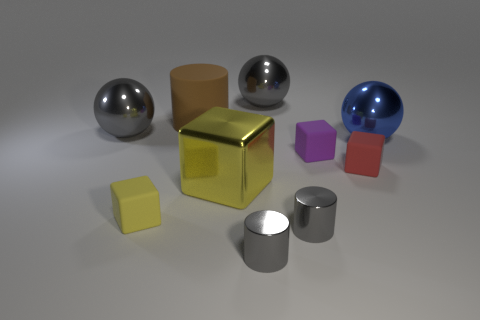There is a cube that is both on the left side of the purple matte cube and to the right of the big brown matte object; what color is it?
Provide a short and direct response. Yellow. Is there a tiny yellow cube that is to the right of the large thing that is in front of the blue metallic sphere?
Provide a succinct answer. No. Are there the same number of purple matte blocks to the right of the red rubber object and big brown cylinders?
Provide a short and direct response. No. There is a tiny matte block that is to the left of the big gray ball to the right of the large yellow shiny block; what number of large blue shiny spheres are to the right of it?
Give a very brief answer. 1. Is there a shiny cube of the same size as the brown matte cylinder?
Keep it short and to the point. Yes. Are there fewer blue spheres that are left of the big blue shiny thing than small gray shiny objects?
Make the answer very short. Yes. What is the material of the gray sphere in front of the cylinder that is behind the red cube that is behind the large yellow metallic thing?
Your answer should be very brief. Metal. Is the number of yellow shiny things that are left of the small red cube greater than the number of tiny things in front of the large brown cylinder?
Give a very brief answer. No. What number of rubber objects are either brown spheres or blue spheres?
Keep it short and to the point. 0. What shape is the thing that is the same color as the big cube?
Keep it short and to the point. Cube. 